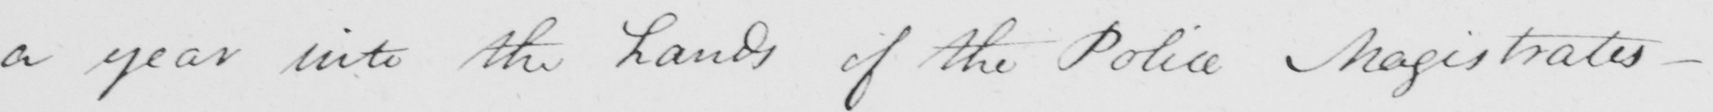What is written in this line of handwriting? a year into the hands of the Police Magistrates - 